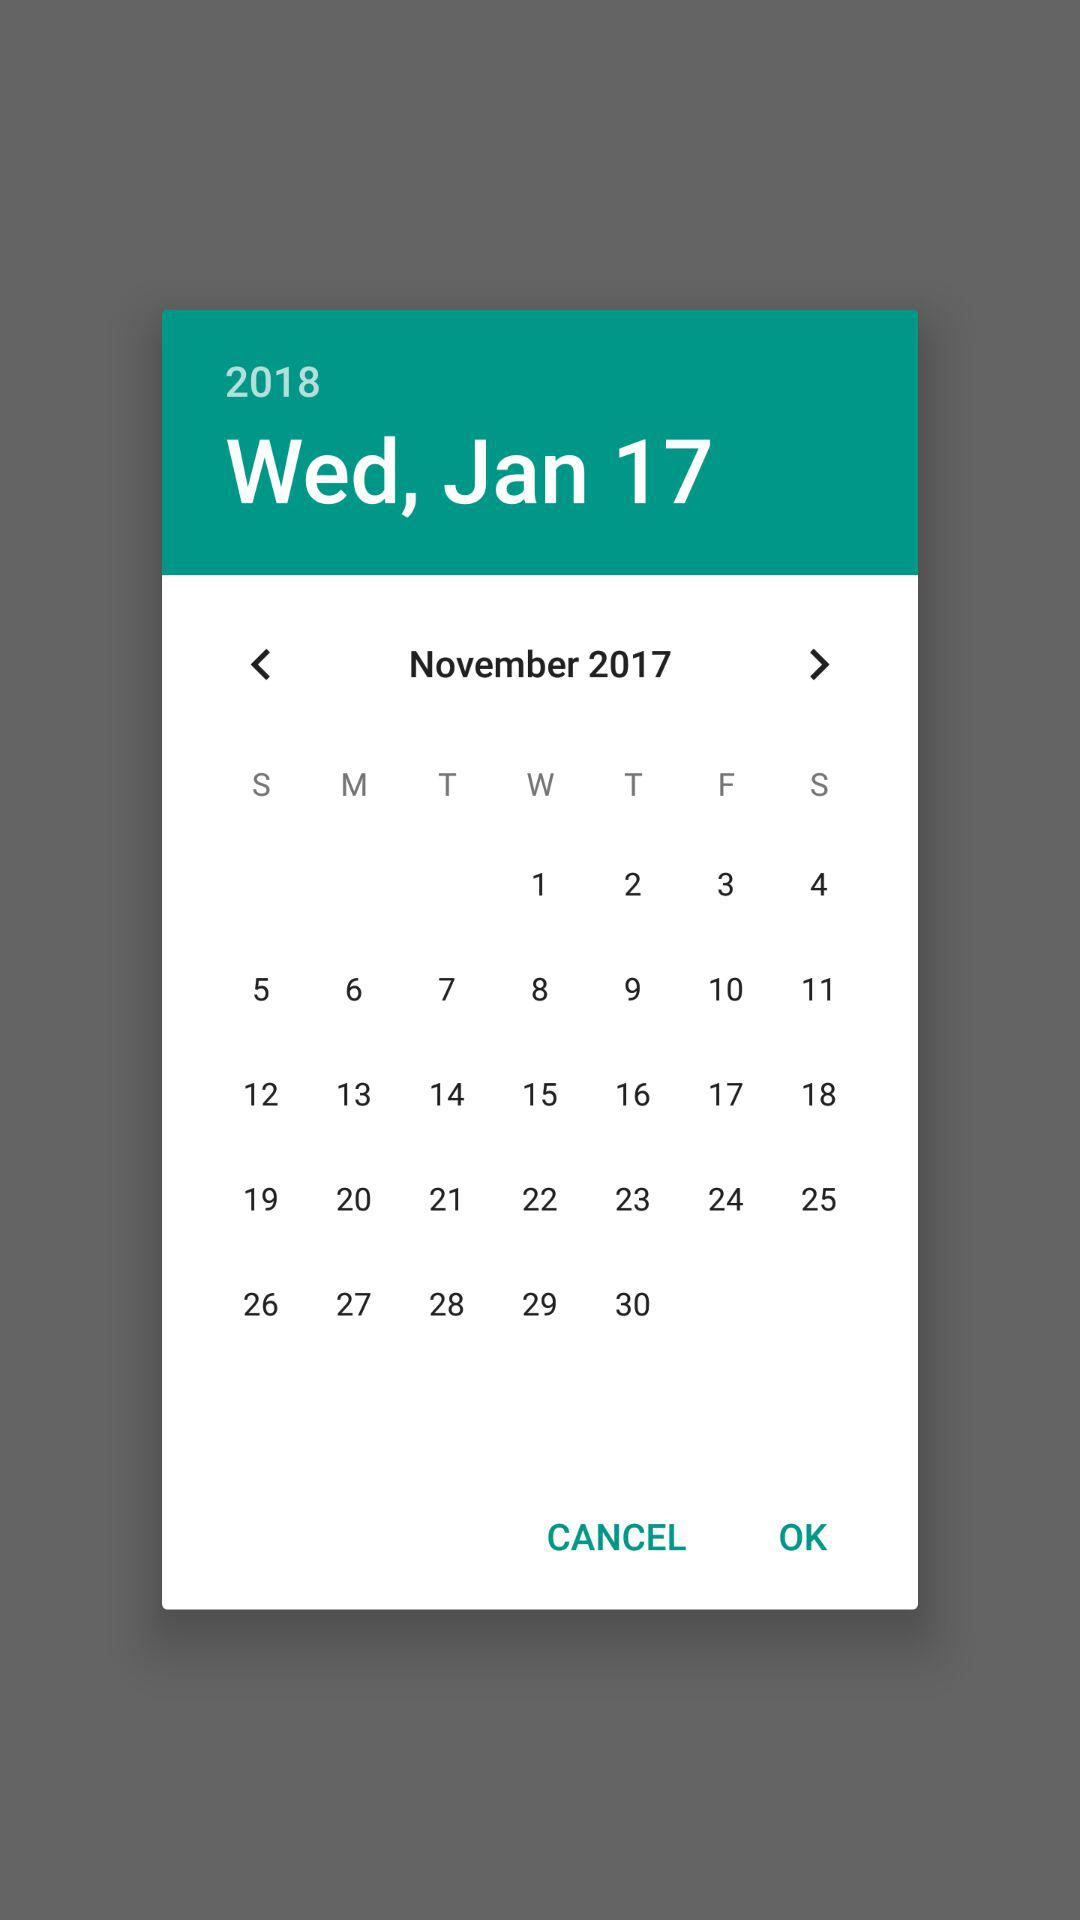What is the selected year? The selected year is 2018. 